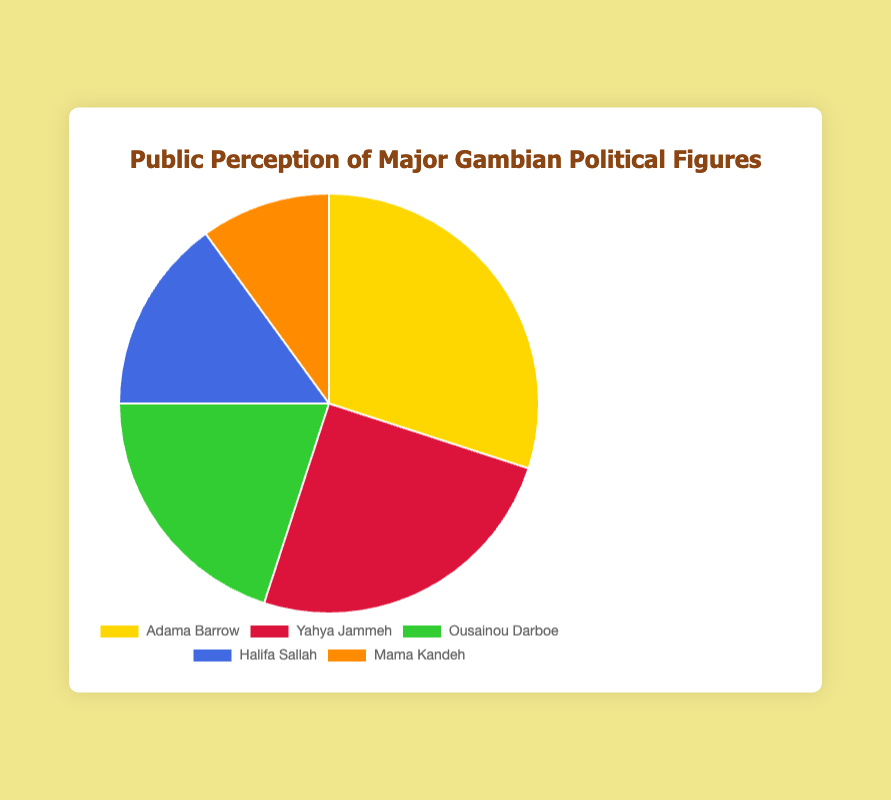How many political figures have a public perception of 20% or more? Adama Barrow has 30%, Yahya Jammeh has 25%, and Ousainou Darboe has 20%, which makes these three figures have a public perception of 20% or more.
Answer: 3 What is the combined public perception percentage for Halifa Sallah and Mama Kandeh? Halifa Sallah has 15% and Mama Kandeh has 10%. Adding them together gives 15% + 10% = 25%.
Answer: 25% Which political figure has the highest public perception percentage? By referring to the data, Adama Barrow has the highest public perception at 30%.
Answer: Adama Barrow Is Ousainou Darboe's public perception percentage greater than or less than that of Yahya Jammeh? Ousainou Darboe has 20% while Yahya Jammeh has 25%. Therefore, Ousainou Darboe's percentage is less than Yahya Jammeh's.
Answer: Less than What is the difference in public perception between Adama Barrow and Mama Kandeh? Adama Barrow has a public perception of 30% and Mama Kandeh has 10%. The difference is 30% - 10% = 20%.
Answer: 20% If you sum the public perception percentages of the top three political figures, what will it be? Adama Barrow (30%), Yahya Jammeh (25%), and Ousainou Darboe (20%). Summing these gives 30% + 25% + 20% = 75%.
Answer: 75% Which slice on the pie chart is colored gold? The color gold is associated with Adama Barrow's segment.
Answer: Adama Barrow How does the public perception of Halifa Sallah compare to Ousainou Darboe? Halifa Sallah has a public perception of 15%, which is 5% less than Ousainou Darboe's 20%.
Answer: Less By what percentage is Yahya Jammeh's perception higher than Halifa Sallah’s? Yahya Jammeh has a public perception of 25% and Halifa Sallah has 15%. The difference is 25% - 15% = 10%.
Answer: 10% What percentage of the public perception does Mama Kandeh represent relative to the total presented in the pie chart? The total percentage in the pie chart is 100% as it represents the whole. Since Mama Kandeh has 10%, he represents 10% of the total perception.
Answer: 10% 